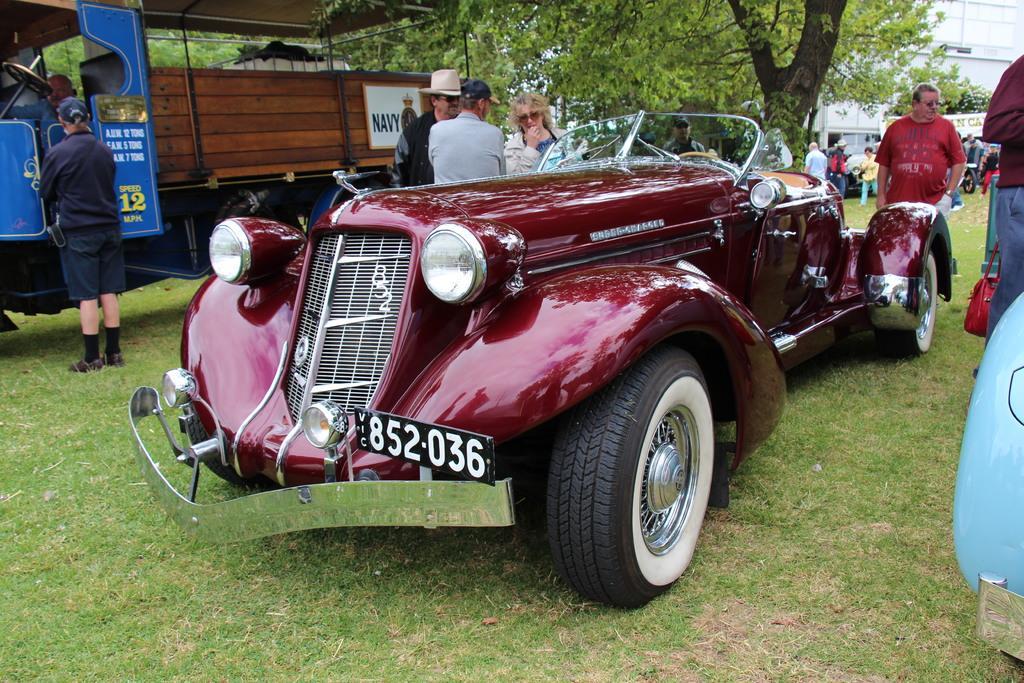Could you give a brief overview of what you see in this image? As we can see in the image there is a car, truck, few people here and there, grass, buildings and a tree. 